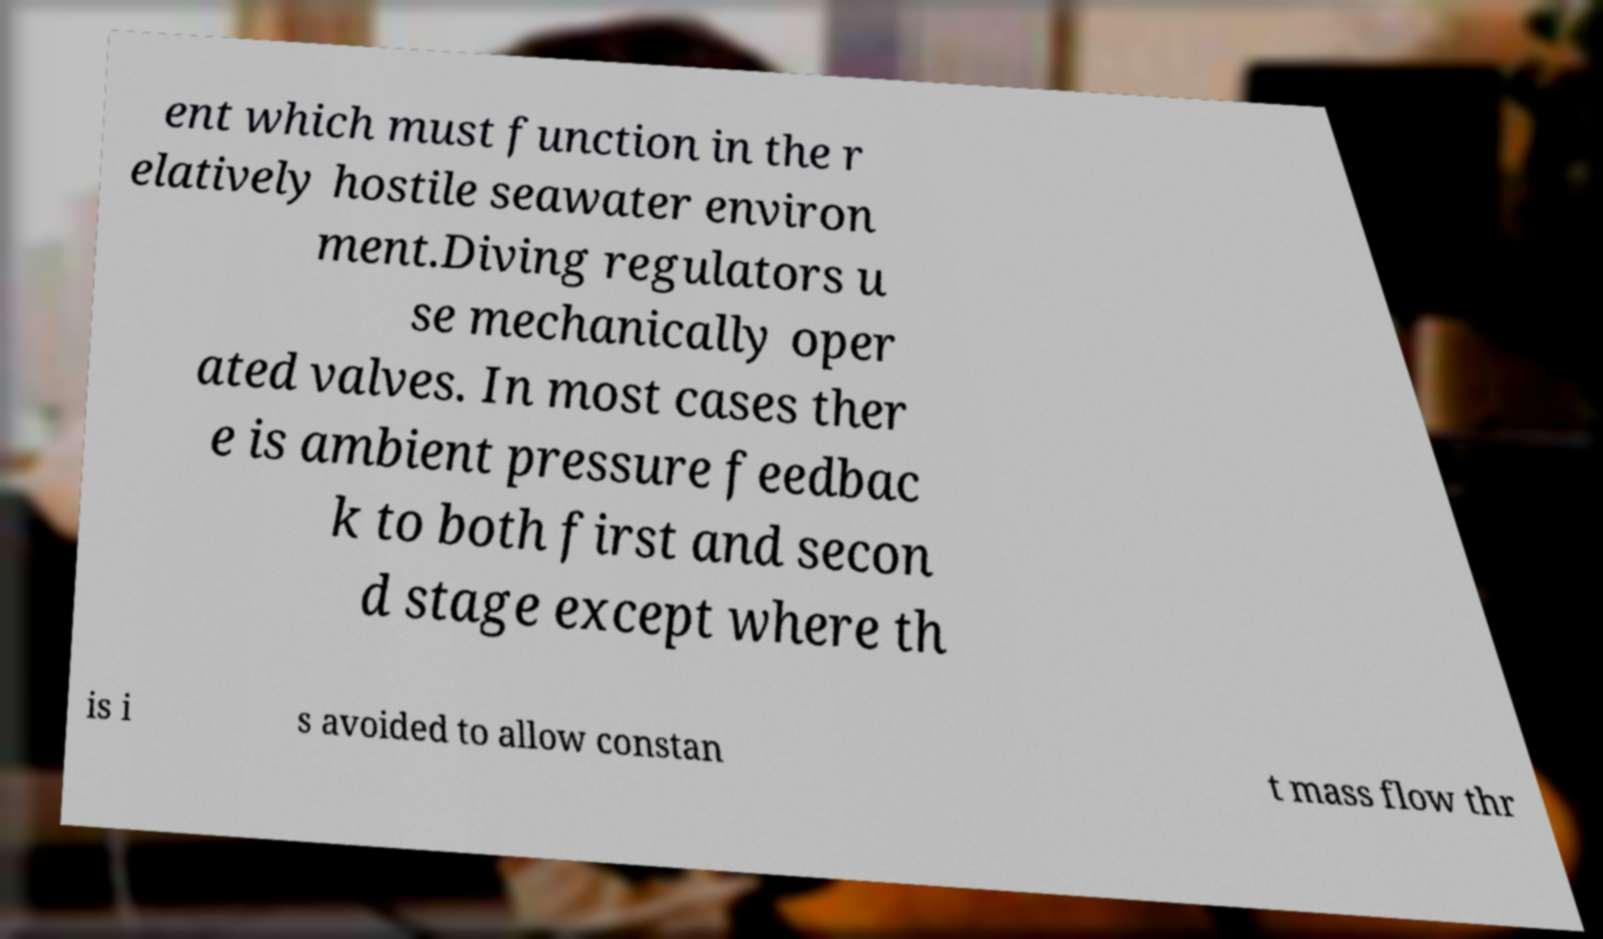I need the written content from this picture converted into text. Can you do that? ent which must function in the r elatively hostile seawater environ ment.Diving regulators u se mechanically oper ated valves. In most cases ther e is ambient pressure feedbac k to both first and secon d stage except where th is i s avoided to allow constan t mass flow thr 